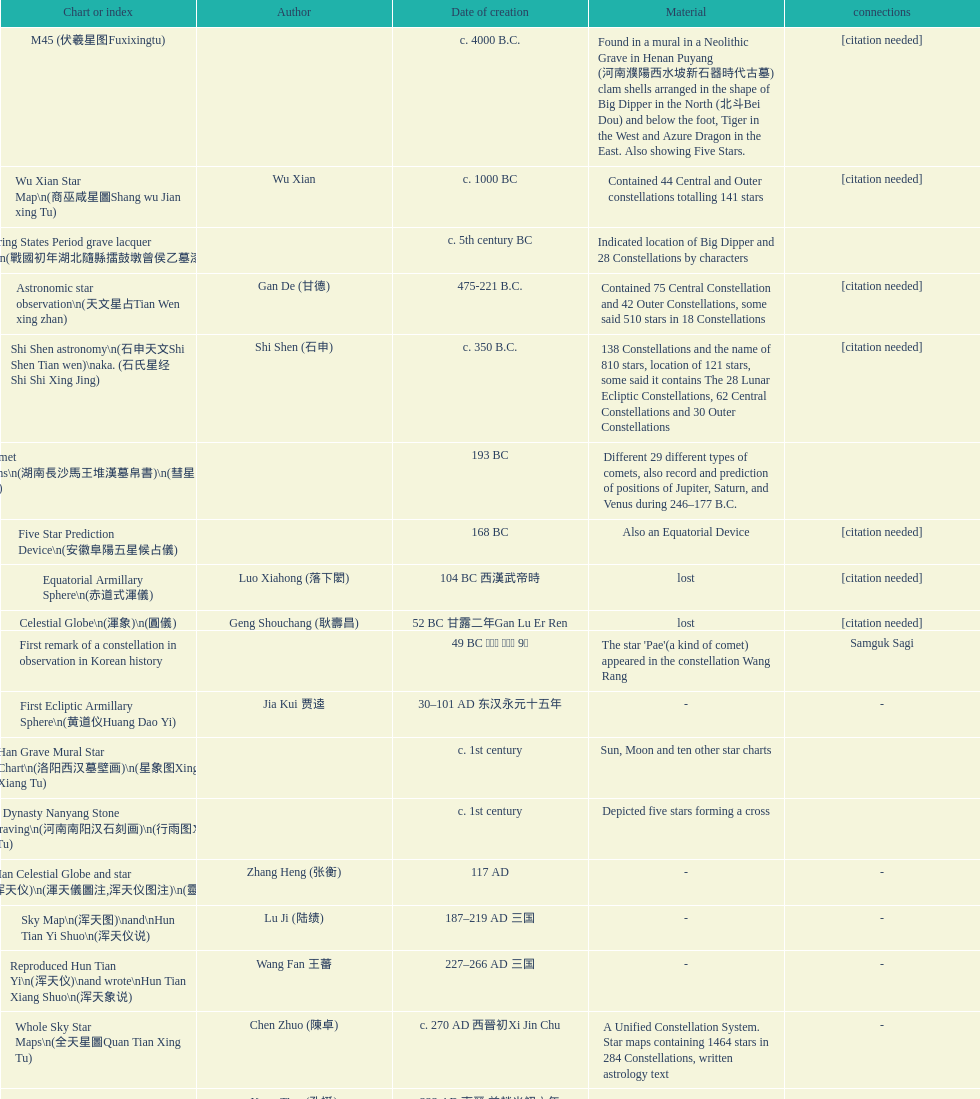When was the first map or catalog created? C. 4000 b.c. 